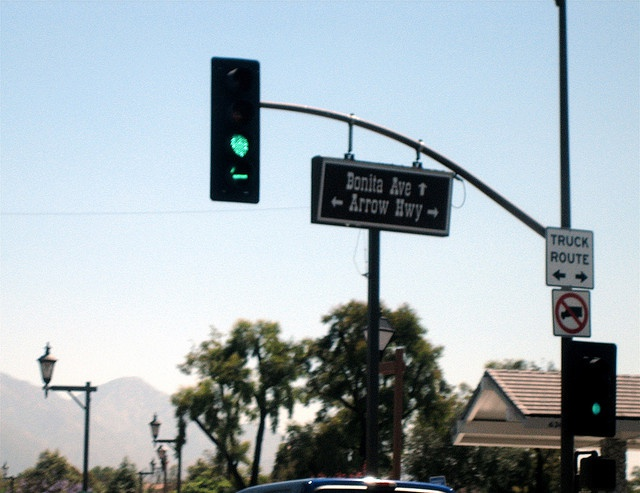Describe the objects in this image and their specific colors. I can see traffic light in lightblue, black, teal, aquamarine, and turquoise tones, traffic light in lightblue, black, teal, and gray tones, and truck in lightblue, black, white, navy, and darkgray tones in this image. 